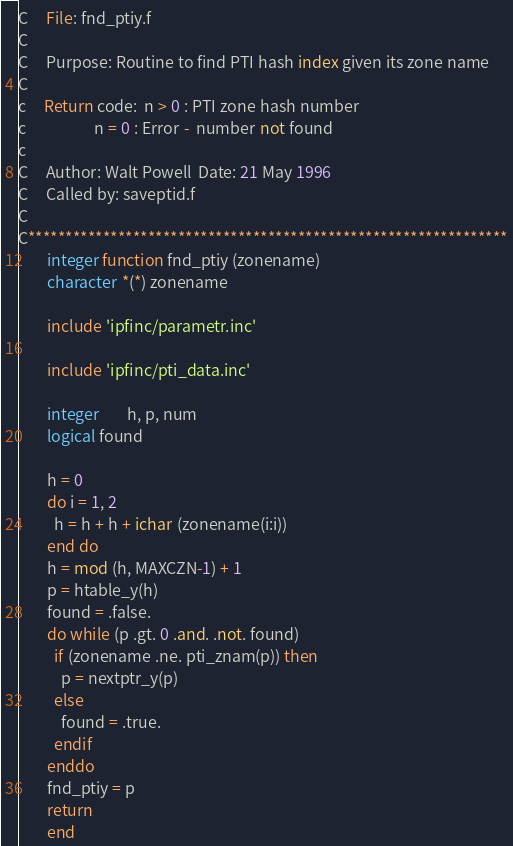<code> <loc_0><loc_0><loc_500><loc_500><_FORTRAN_>C     File: fnd_ptiy.f
C
C     Purpose: Routine to find PTI hash index given its zone name
C
c     Return code:  n > 0 : PTI zone hash number
c                   n = 0 : Error -  number not found
c
C     Author: Walt Powell  Date: 21 May 1996
C     Called by: saveptid.f
C
C****************************************************************
        integer function fnd_ptiy (zonename)
        character *(*) zonename

        include 'ipfinc/parametr.inc'

        include 'ipfinc/pti_data.inc'

        integer        h, p, num
        logical found

        h = 0
        do i = 1, 2
          h = h + h + ichar (zonename(i:i))
        end do
        h = mod (h, MAXCZN-1) + 1
        p = htable_y(h)
        found = .false.
        do while (p .gt. 0 .and. .not. found)
          if (zonename .ne. pti_znam(p)) then
            p = nextptr_y(p)
          else
            found = .true.
          endif
        enddo
        fnd_ptiy = p   
        return
        end
</code> 